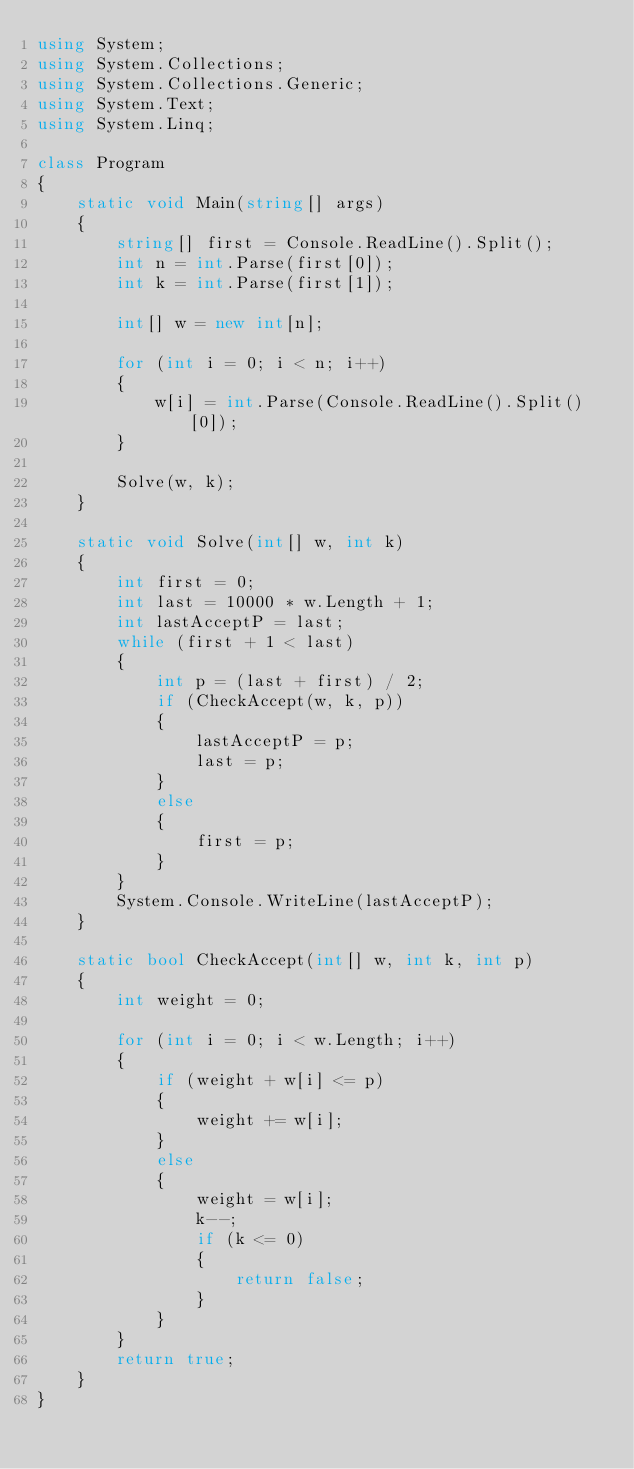<code> <loc_0><loc_0><loc_500><loc_500><_C#_>using System;
using System.Collections;
using System.Collections.Generic;
using System.Text;
using System.Linq;

class Program
{
	static void Main(string[] args)
	{
		string[] first = Console.ReadLine().Split();
		int n = int.Parse(first[0]);
		int k = int.Parse(first[1]);
		
		int[] w = new int[n];
		
		for (int i = 0; i < n; i++)
		{
			w[i] = int.Parse(Console.ReadLine().Split()[0]);
		}
		
		Solve(w, k);
	}

	static void Solve(int[] w, int k)
	{
		int first = 0;
		int last = 10000 * w.Length + 1;
		int lastAcceptP = last;
		while (first + 1 < last)
		{
			int p = (last + first) / 2;
			if (CheckAccept(w, k, p))
			{
				lastAcceptP = p;
				last = p;
			}
			else
			{
				first = p;
			}
		}
		System.Console.WriteLine(lastAcceptP);
	}

	static bool CheckAccept(int[] w, int k, int p)
	{
		int weight = 0;

		for (int i = 0; i < w.Length; i++)
		{
			if (weight + w[i] <= p)
			{
				weight += w[i];
			}
			else
			{
				weight = w[i];
				k--;
				if (k <= 0)
				{
					return false;
				}
			}
		}
		return true;
	}
}

</code> 